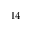Convert formula to latex. <formula><loc_0><loc_0><loc_500><loc_500>^ { 1 4 }</formula> 